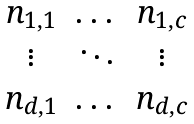Convert formula to latex. <formula><loc_0><loc_0><loc_500><loc_500>\begin{matrix} n _ { 1 , 1 } & \dots & n _ { 1 , c } \\ \vdots & \ddots & \vdots \\ n _ { d , 1 } & \dots & n _ { d , c } \end{matrix}</formula> 